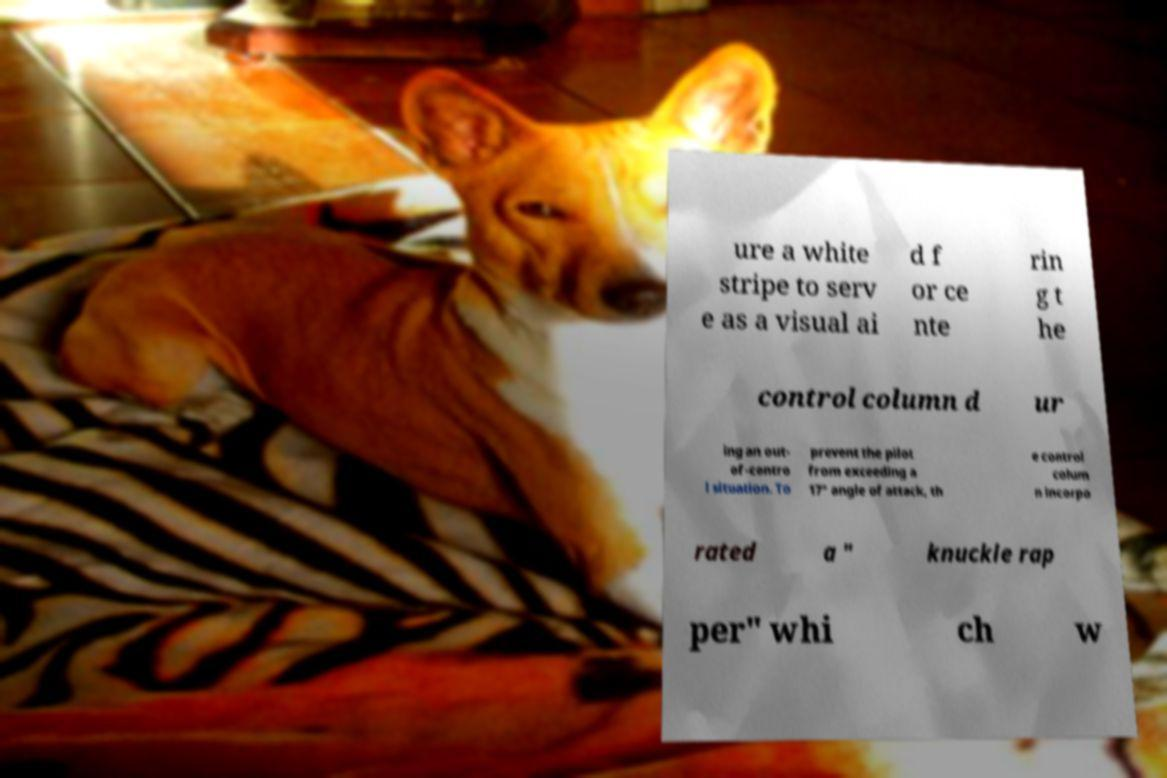Can you read and provide the text displayed in the image?This photo seems to have some interesting text. Can you extract and type it out for me? ure a white stripe to serv e as a visual ai d f or ce nte rin g t he control column d ur ing an out- of-contro l situation. To prevent the pilot from exceeding a 17° angle of attack, th e control colum n incorpo rated a " knuckle rap per" whi ch w 